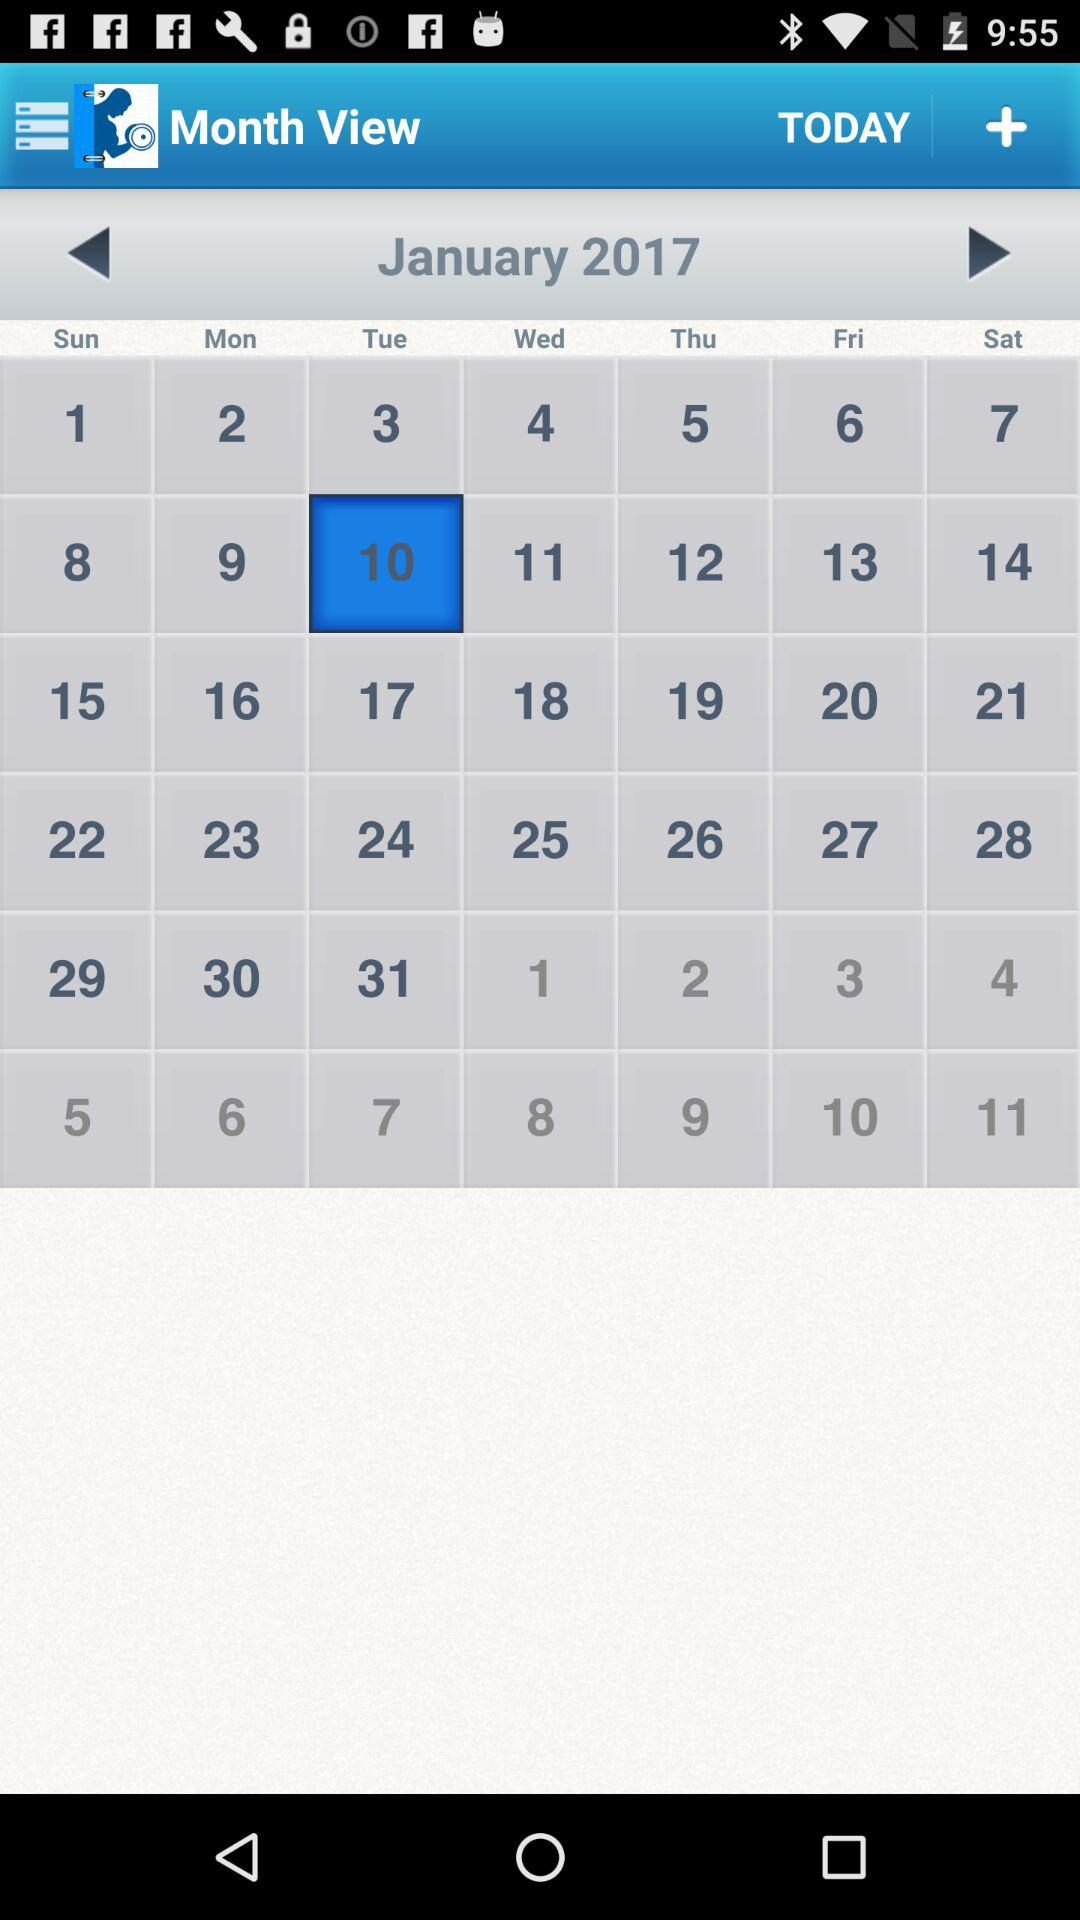Which holiday falls on Tuesday, January 10, 2017?
When the provided information is insufficient, respond with <no answer>. <no answer> 